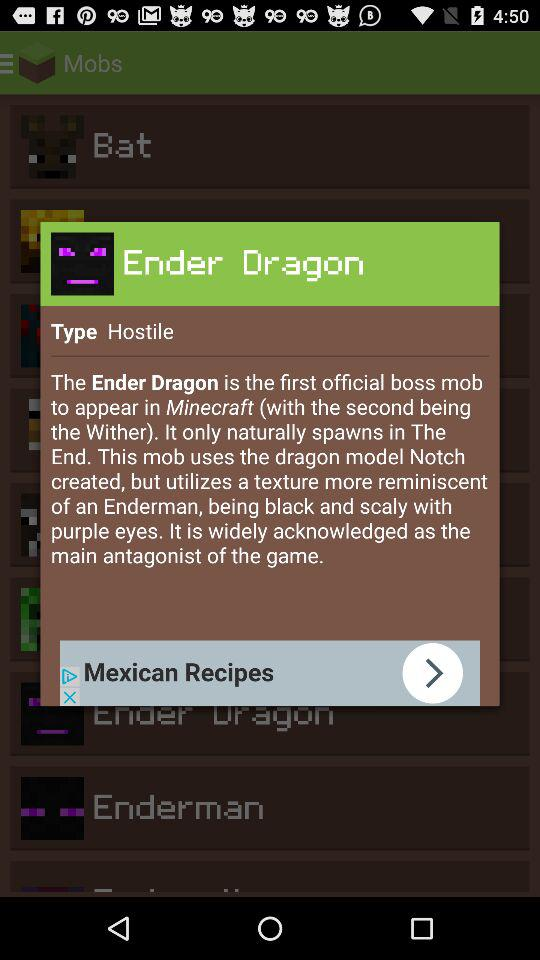What is the other name for "Blocks of Diamond"? The other name for "Blocks of Diamond" is "Diamond Blocks". 